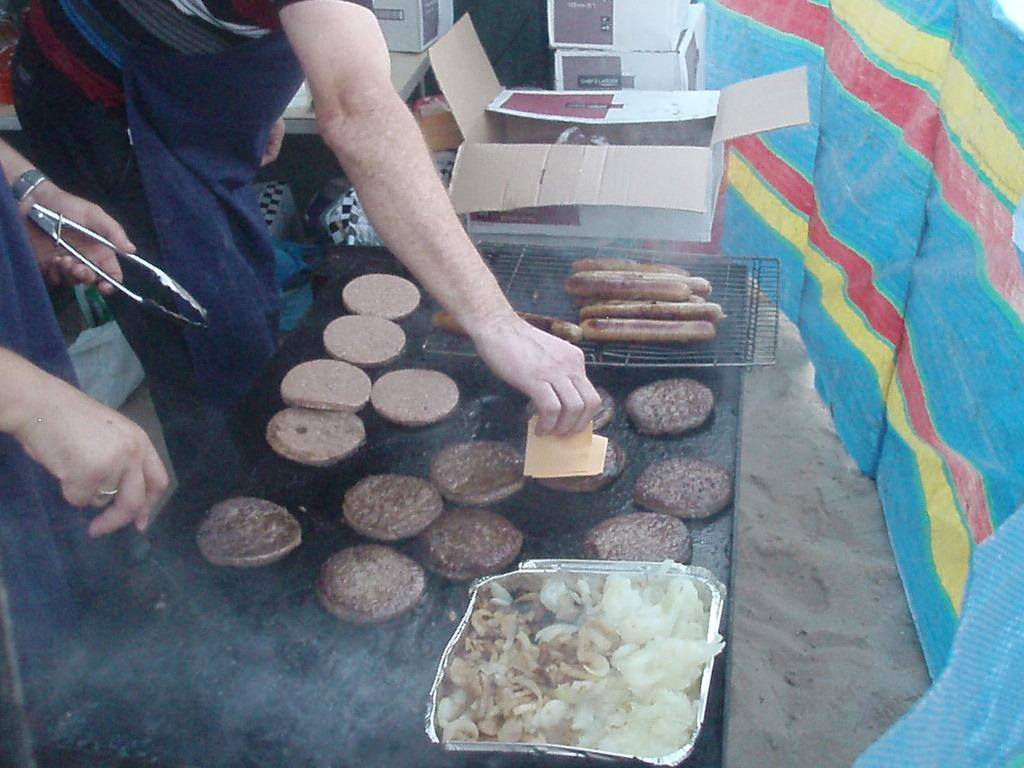What are the two persons in the image doing? They are cooking hot dogs and pancakes in the image. What type of food can be seen being prepared? Hot dogs and pancakes are being prepared in the image. What is the texture of the ground in the image? There is sand at the bottom of the image. What color is the cloth on the right side of the image? The cloth on the right side of the image is blue. What objects can be seen in the background of the image? There are boxes in the background of the image. What type of quartz can be seen in the image? There is no quartz present in the image. Is there a record player visible in the image? There is no record player or record visible in the image. 